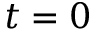<formula> <loc_0><loc_0><loc_500><loc_500>t = 0</formula> 